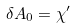Convert formula to latex. <formula><loc_0><loc_0><loc_500><loc_500>\delta A _ { 0 } = \chi ^ { \prime }</formula> 